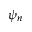<formula> <loc_0><loc_0><loc_500><loc_500>\psi _ { n }</formula> 